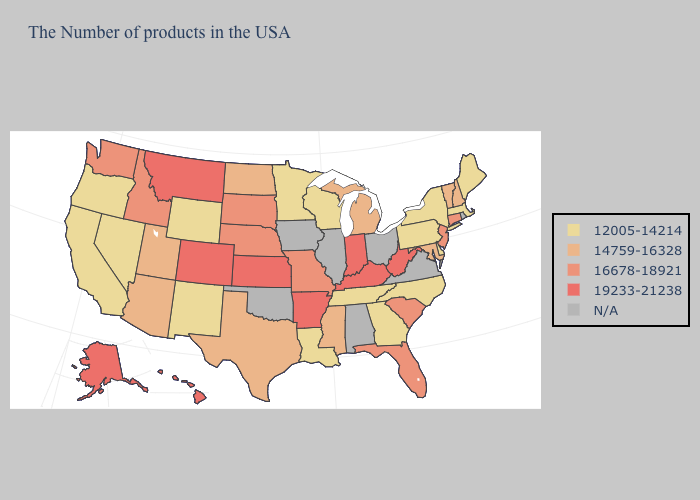Name the states that have a value in the range 19233-21238?
Write a very short answer. West Virginia, Kentucky, Indiana, Arkansas, Kansas, Colorado, Montana, Alaska, Hawaii. Does the map have missing data?
Keep it brief. Yes. What is the value of West Virginia?
Be succinct. 19233-21238. Does Vermont have the lowest value in the USA?
Keep it brief. No. Which states have the lowest value in the West?
Write a very short answer. Wyoming, New Mexico, Nevada, California, Oregon. Among the states that border Kansas , which have the lowest value?
Quick response, please. Missouri, Nebraska. What is the highest value in states that border Alabama?
Answer briefly. 16678-18921. Does Texas have the highest value in the USA?
Concise answer only. No. Name the states that have a value in the range 16678-18921?
Give a very brief answer. Connecticut, New Jersey, South Carolina, Florida, Missouri, Nebraska, South Dakota, Idaho, Washington. Name the states that have a value in the range 14759-16328?
Be succinct. New Hampshire, Vermont, Maryland, Michigan, Mississippi, Texas, North Dakota, Utah, Arizona. Does Arkansas have the lowest value in the USA?
Keep it brief. No. Name the states that have a value in the range 19233-21238?
Write a very short answer. West Virginia, Kentucky, Indiana, Arkansas, Kansas, Colorado, Montana, Alaska, Hawaii. What is the value of North Dakota?
Keep it brief. 14759-16328. What is the value of Missouri?
Answer briefly. 16678-18921. 